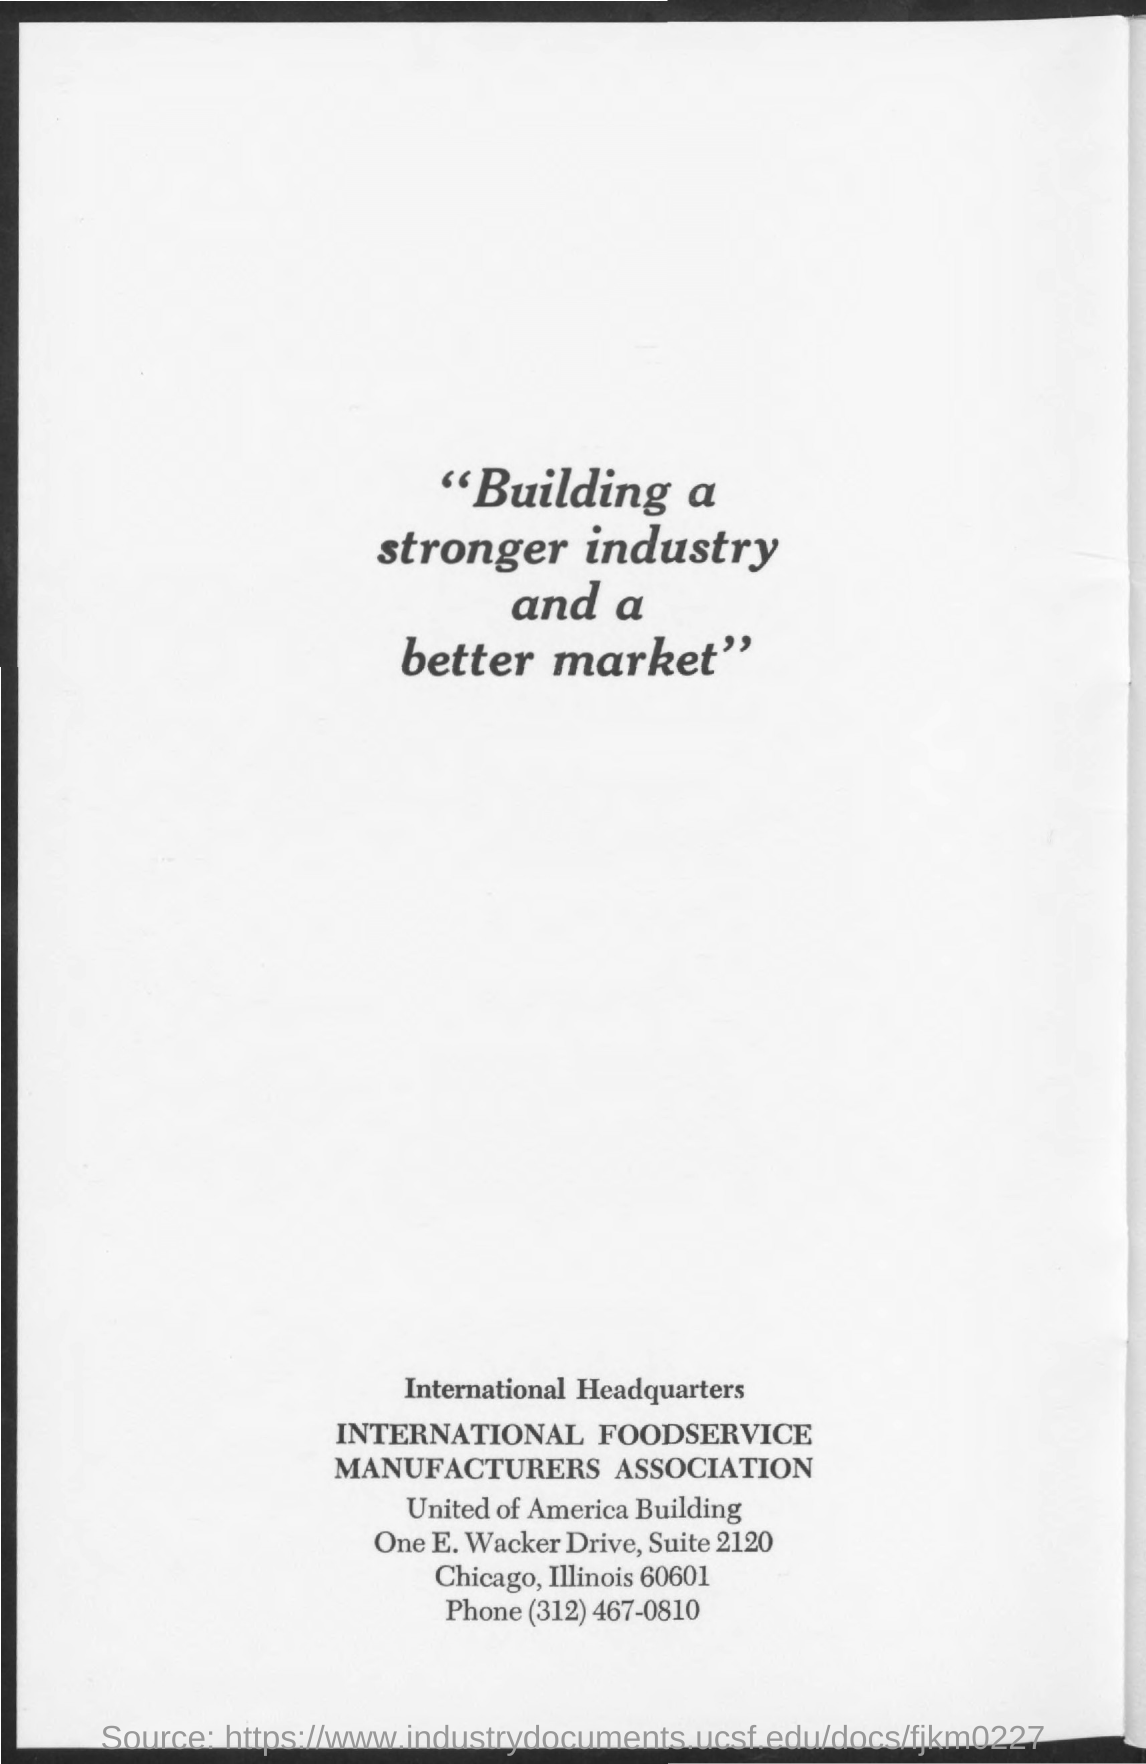Give some essential details in this illustration. The phone number mentioned in the given page is (312) 467-0810. 